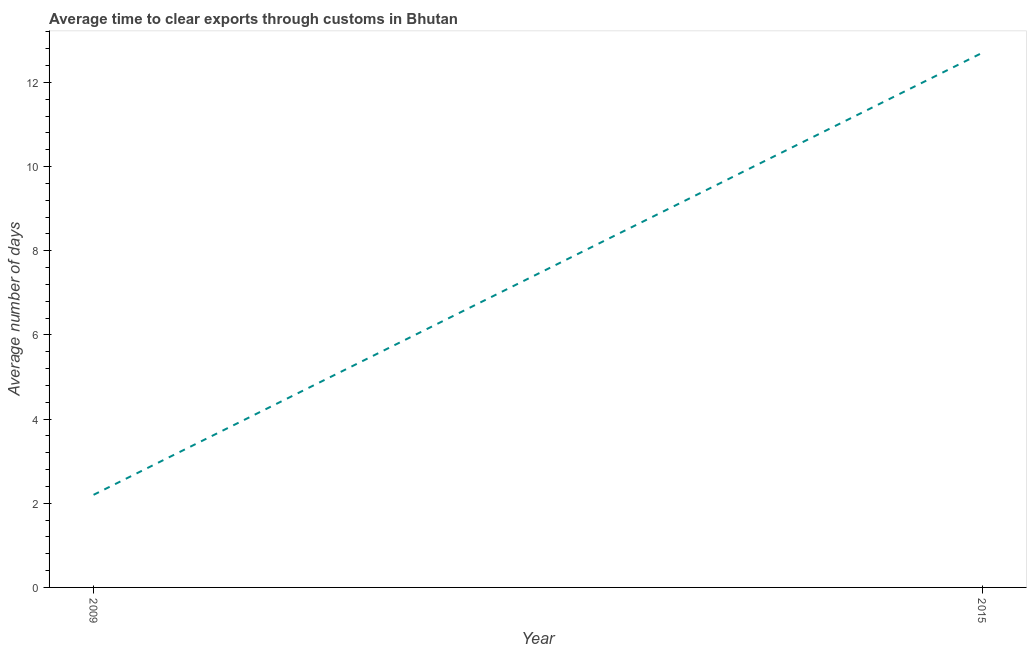What is the time to clear exports through customs in 2015?
Offer a very short reply. 12.7. In which year was the time to clear exports through customs maximum?
Your answer should be compact. 2015. What is the sum of the time to clear exports through customs?
Provide a succinct answer. 14.9. What is the average time to clear exports through customs per year?
Ensure brevity in your answer.  7.45. What is the median time to clear exports through customs?
Provide a short and direct response. 7.45. What is the ratio of the time to clear exports through customs in 2009 to that in 2015?
Ensure brevity in your answer.  0.17. How many lines are there?
Provide a short and direct response. 1. How many years are there in the graph?
Provide a short and direct response. 2. Does the graph contain any zero values?
Provide a succinct answer. No. Does the graph contain grids?
Provide a succinct answer. No. What is the title of the graph?
Your answer should be compact. Average time to clear exports through customs in Bhutan. What is the label or title of the X-axis?
Your answer should be compact. Year. What is the label or title of the Y-axis?
Keep it short and to the point. Average number of days. What is the difference between the Average number of days in 2009 and 2015?
Provide a succinct answer. -10.5. What is the ratio of the Average number of days in 2009 to that in 2015?
Your response must be concise. 0.17. 